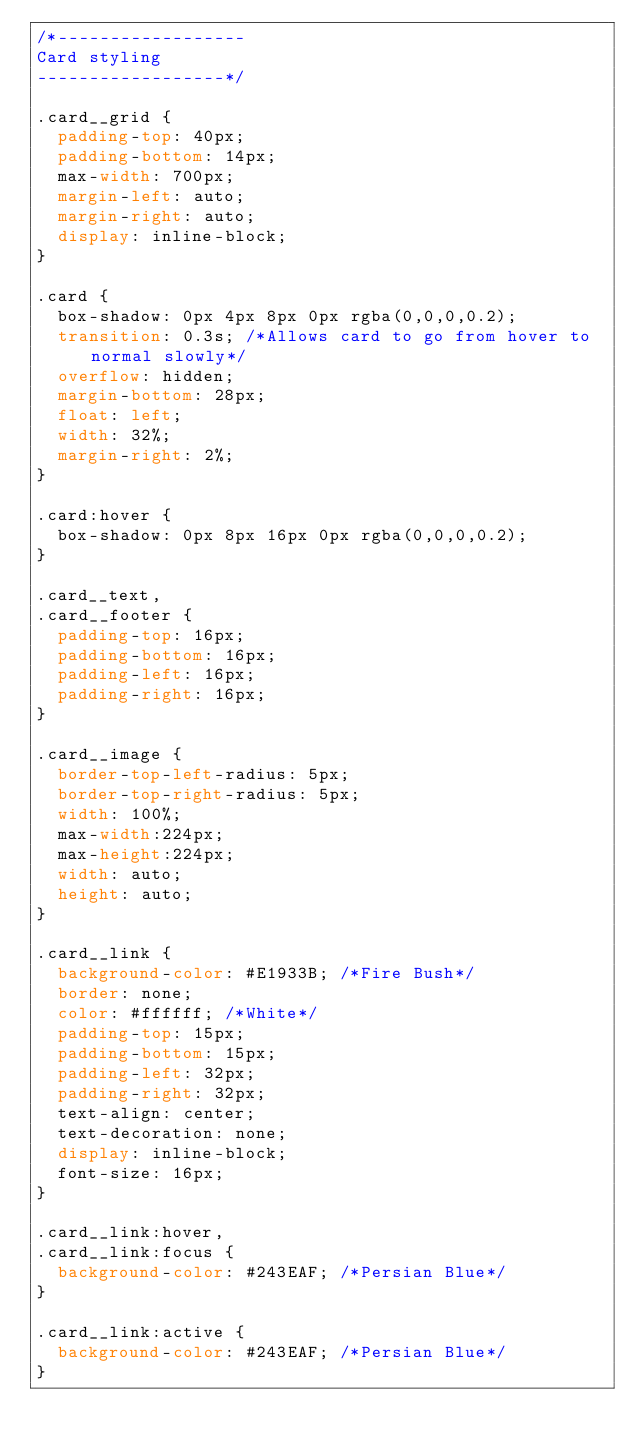Convert code to text. <code><loc_0><loc_0><loc_500><loc_500><_CSS_>/*------------------
Card styling
------------------*/

.card__grid {
  padding-top: 40px;
  padding-bottom: 14px;
  max-width: 700px;
  margin-left: auto;
  margin-right: auto;
  display: inline-block;
}

.card {
  box-shadow: 0px 4px 8px 0px rgba(0,0,0,0.2);
  transition: 0.3s; /*Allows card to go from hover to normal slowly*/
  overflow: hidden;
  margin-bottom: 28px;
  float: left;
  width: 32%;
  margin-right: 2%;
}

.card:hover {
  box-shadow: 0px 8px 16px 0px rgba(0,0,0,0.2);
}

.card__text,
.card__footer {
  padding-top: 16px;
  padding-bottom: 16px;
  padding-left: 16px;
  padding-right: 16px;
}

.card__image {
  border-top-left-radius: 5px;
  border-top-right-radius: 5px;
  width: 100%;
  max-width:224px;
  max-height:224px;
  width: auto;
  height: auto;
}

.card__link {
  background-color: #E1933B; /*Fire Bush*/
  border: none;
  color: #ffffff; /*White*/
  padding-top: 15px;
  padding-bottom: 15px;
  padding-left: 32px;
  padding-right: 32px;
  text-align: center;
  text-decoration: none;
  display: inline-block;
  font-size: 16px;
}

.card__link:hover,
.card__link:focus {
  background-color: #243EAF; /*Persian Blue*/
}

.card__link:active {
  background-color: #243EAF; /*Persian Blue*/
}
</code> 